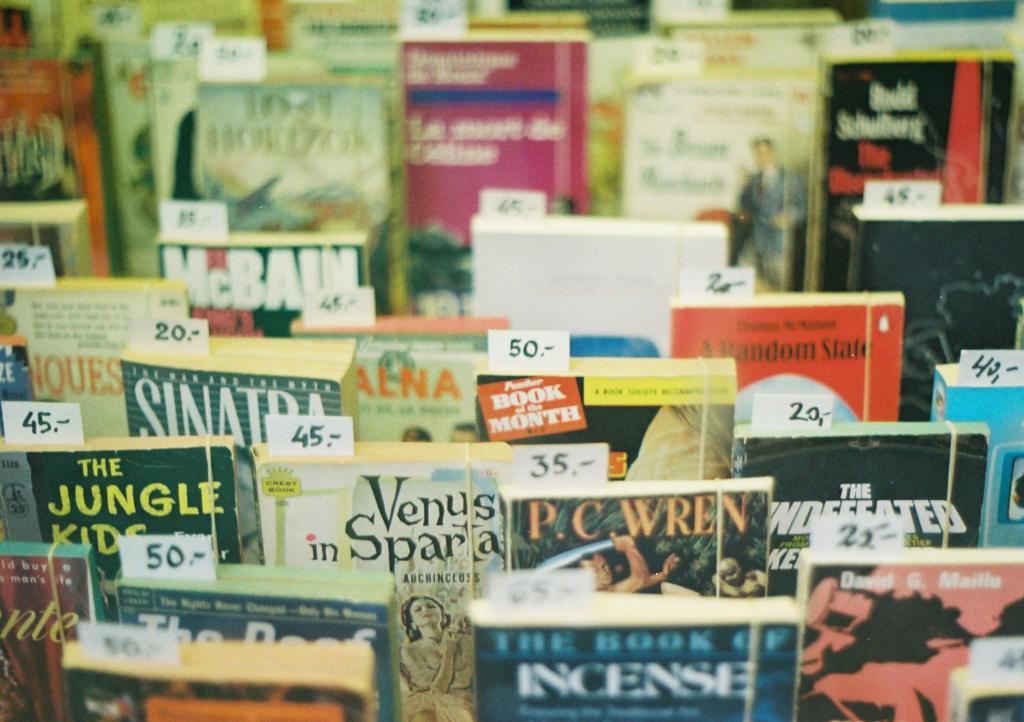How much is the book of the month?
Your response must be concise. Unanswerable. What is the name after p.c.?
Offer a terse response. Wren. 